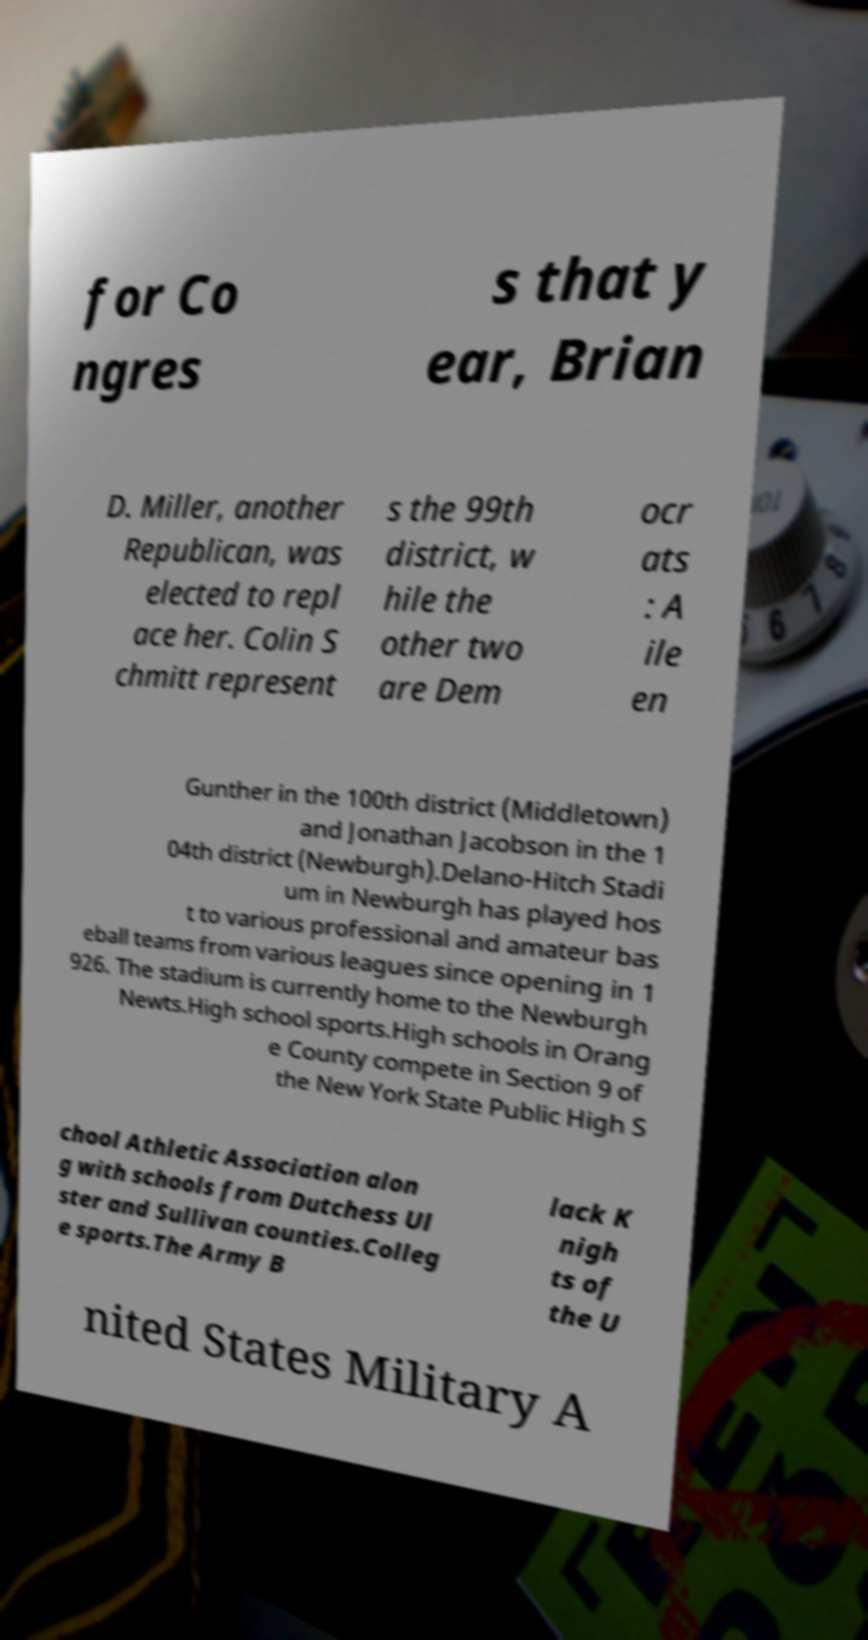For documentation purposes, I need the text within this image transcribed. Could you provide that? for Co ngres s that y ear, Brian D. Miller, another Republican, was elected to repl ace her. Colin S chmitt represent s the 99th district, w hile the other two are Dem ocr ats : A ile en Gunther in the 100th district (Middletown) and Jonathan Jacobson in the 1 04th district (Newburgh).Delano-Hitch Stadi um in Newburgh has played hos t to various professional and amateur bas eball teams from various leagues since opening in 1 926. The stadium is currently home to the Newburgh Newts.High school sports.High schools in Orang e County compete in Section 9 of the New York State Public High S chool Athletic Association alon g with schools from Dutchess Ul ster and Sullivan counties.Colleg e sports.The Army B lack K nigh ts of the U nited States Military A 